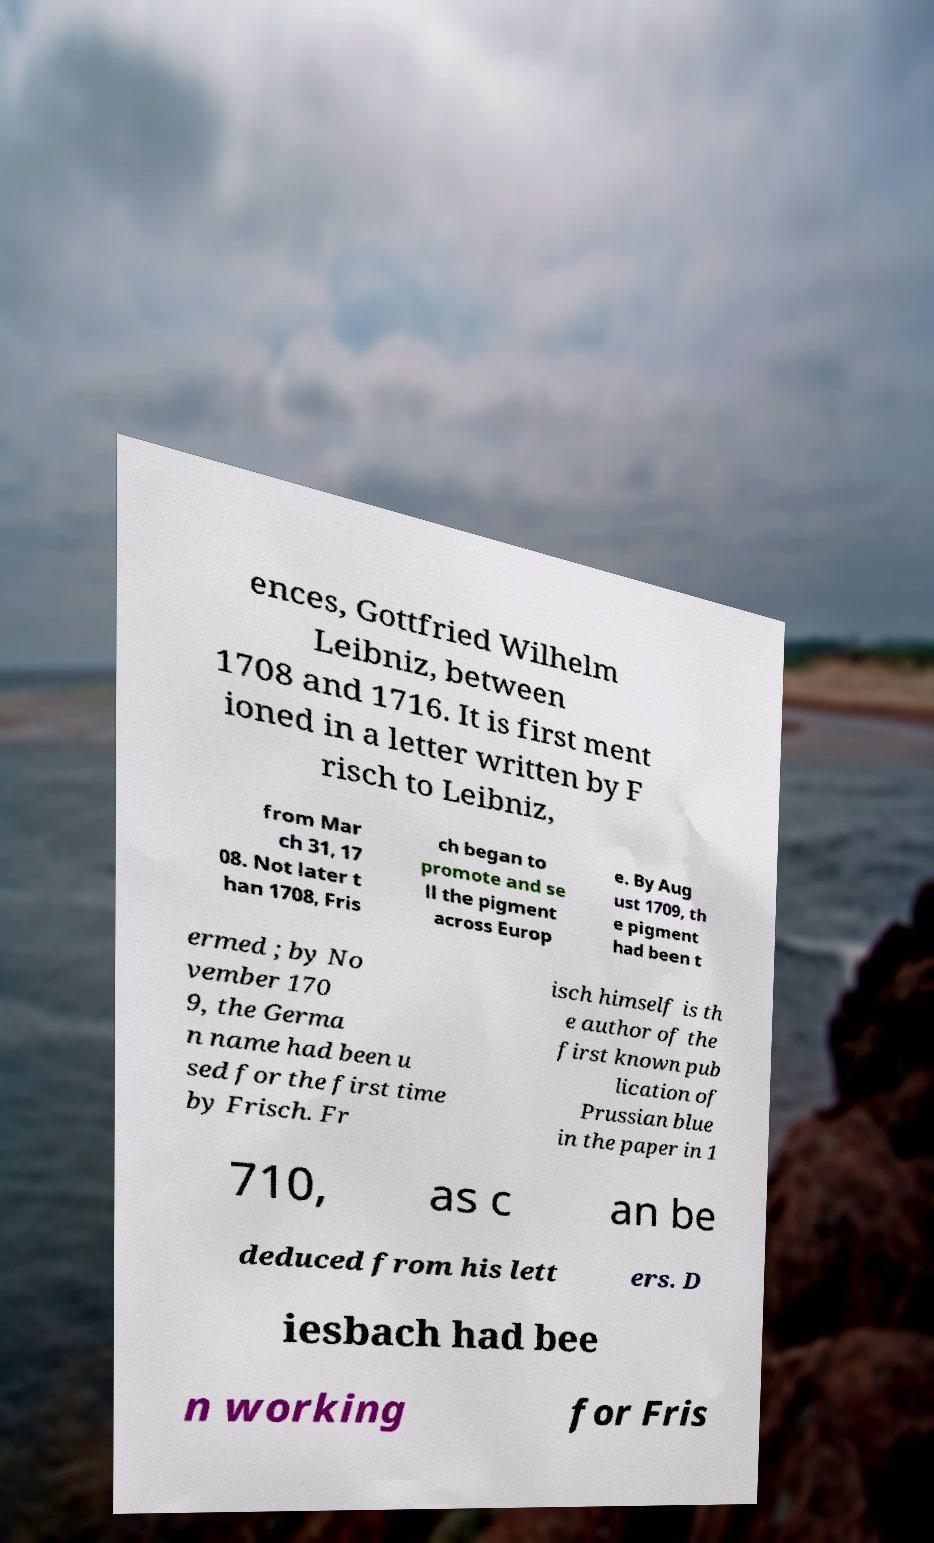Could you assist in decoding the text presented in this image and type it out clearly? ences, Gottfried Wilhelm Leibniz, between 1708 and 1716. It is first ment ioned in a letter written by F risch to Leibniz, from Mar ch 31, 17 08. Not later t han 1708, Fris ch began to promote and se ll the pigment across Europ e. By Aug ust 1709, th e pigment had been t ermed ; by No vember 170 9, the Germa n name had been u sed for the first time by Frisch. Fr isch himself is th e author of the first known pub lication of Prussian blue in the paper in 1 710, as c an be deduced from his lett ers. D iesbach had bee n working for Fris 